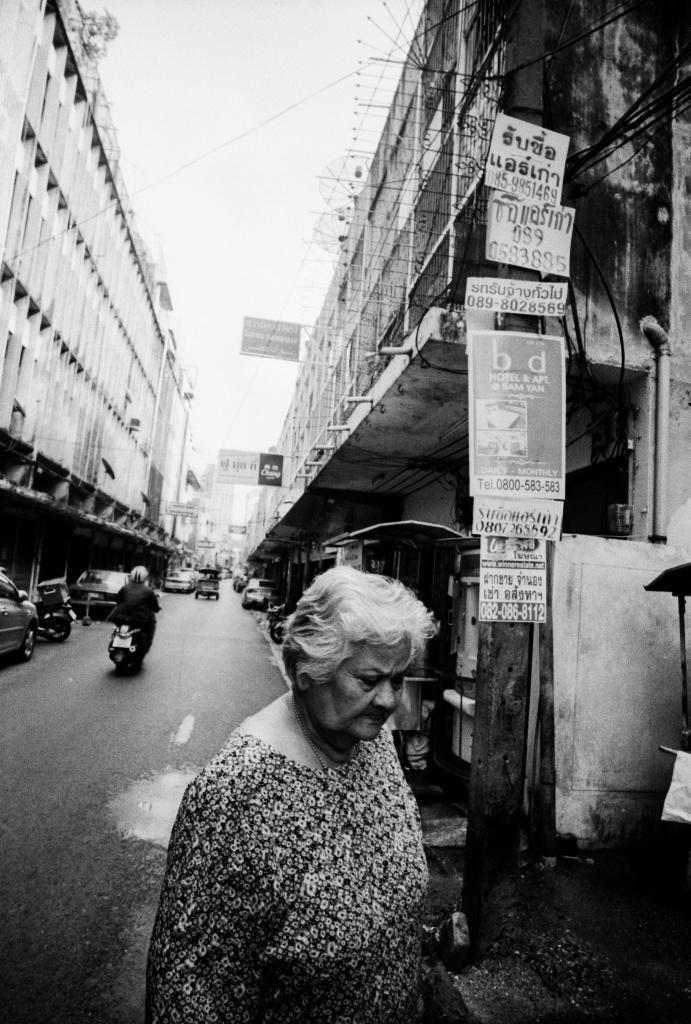Could you give a brief overview of what you see in this image? There is one women present at the bottom of this image. We can see the buildings in the background. There are cars and a person on a bike is in the middle of this image. The sky is at the top of this image. 